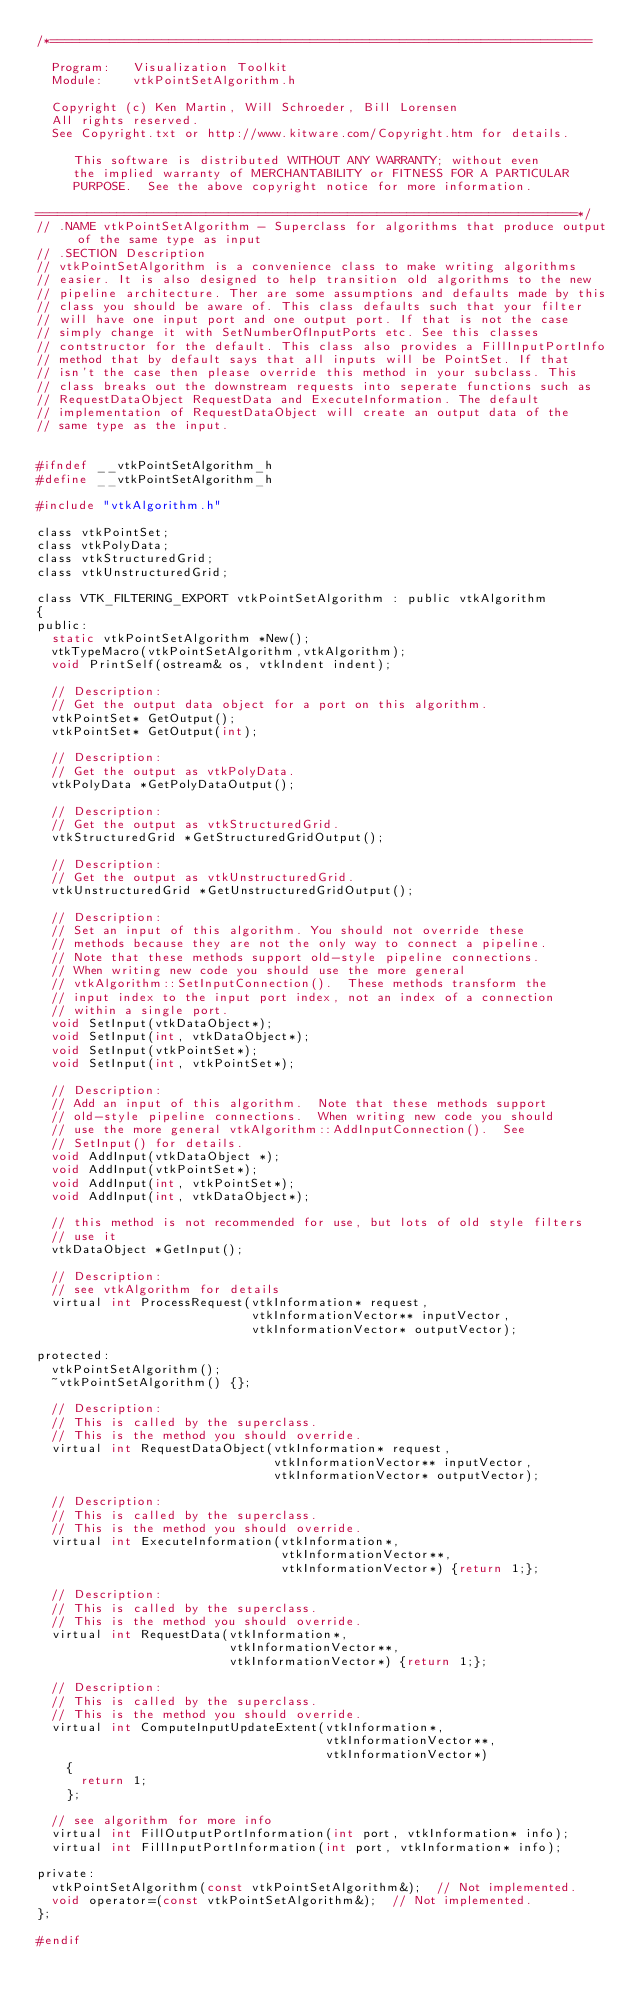<code> <loc_0><loc_0><loc_500><loc_500><_C_>/*=========================================================================

  Program:   Visualization Toolkit
  Module:    vtkPointSetAlgorithm.h

  Copyright (c) Ken Martin, Will Schroeder, Bill Lorensen
  All rights reserved.
  See Copyright.txt or http://www.kitware.com/Copyright.htm for details.

     This software is distributed WITHOUT ANY WARRANTY; without even
     the implied warranty of MERCHANTABILITY or FITNESS FOR A PARTICULAR
     PURPOSE.  See the above copyright notice for more information.

=========================================================================*/
// .NAME vtkPointSetAlgorithm - Superclass for algorithms that produce output of the same type as input
// .SECTION Description
// vtkPointSetAlgorithm is a convenience class to make writing algorithms
// easier. It is also designed to help transition old algorithms to the new
// pipeline architecture. Ther are some assumptions and defaults made by this
// class you should be aware of. This class defaults such that your filter
// will have one input port and one output port. If that is not the case
// simply change it with SetNumberOfInputPorts etc. See this classes
// contstructor for the default. This class also provides a FillInputPortInfo
// method that by default says that all inputs will be PointSet. If that
// isn't the case then please override this method in your subclass. This
// class breaks out the downstream requests into seperate functions such as
// RequestDataObject RequestData and ExecuteInformation. The default 
// implementation of RequestDataObject will create an output data of the 
// same type as the input. 


#ifndef __vtkPointSetAlgorithm_h
#define __vtkPointSetAlgorithm_h

#include "vtkAlgorithm.h"

class vtkPointSet;
class vtkPolyData;
class vtkStructuredGrid;
class vtkUnstructuredGrid;

class VTK_FILTERING_EXPORT vtkPointSetAlgorithm : public vtkAlgorithm
{
public:
  static vtkPointSetAlgorithm *New();
  vtkTypeMacro(vtkPointSetAlgorithm,vtkAlgorithm);
  void PrintSelf(ostream& os, vtkIndent indent);

  // Description:
  // Get the output data object for a port on this algorithm.
  vtkPointSet* GetOutput();
  vtkPointSet* GetOutput(int);

  // Description:
  // Get the output as vtkPolyData.
  vtkPolyData *GetPolyDataOutput();

  // Description:
  // Get the output as vtkStructuredGrid.
  vtkStructuredGrid *GetStructuredGridOutput();

  // Description:
  // Get the output as vtkUnstructuredGrid.
  vtkUnstructuredGrid *GetUnstructuredGridOutput();

  // Description:
  // Set an input of this algorithm. You should not override these
  // methods because they are not the only way to connect a pipeline.
  // Note that these methods support old-style pipeline connections.
  // When writing new code you should use the more general
  // vtkAlgorithm::SetInputConnection().  These methods transform the
  // input index to the input port index, not an index of a connection
  // within a single port.
  void SetInput(vtkDataObject*);
  void SetInput(int, vtkDataObject*);
  void SetInput(vtkPointSet*);
  void SetInput(int, vtkPointSet*);

  // Description:
  // Add an input of this algorithm.  Note that these methods support
  // old-style pipeline connections.  When writing new code you should
  // use the more general vtkAlgorithm::AddInputConnection().  See
  // SetInput() for details.
  void AddInput(vtkDataObject *);
  void AddInput(vtkPointSet*);
  void AddInput(int, vtkPointSet*);
  void AddInput(int, vtkDataObject*);

  // this method is not recommended for use, but lots of old style filters
  // use it
  vtkDataObject *GetInput();

  // Description:
  // see vtkAlgorithm for details
  virtual int ProcessRequest(vtkInformation* request, 
                             vtkInformationVector** inputVector,
                             vtkInformationVector* outputVector);

protected:
  vtkPointSetAlgorithm();
  ~vtkPointSetAlgorithm() {};
  
  // Description:
  // This is called by the superclass.
  // This is the method you should override.
  virtual int RequestDataObject(vtkInformation* request, 
                                vtkInformationVector** inputVector, 
                                vtkInformationVector* outputVector);
  
  // Description:
  // This is called by the superclass.
  // This is the method you should override.
  virtual int ExecuteInformation(vtkInformation*, 
                                 vtkInformationVector**, 
                                 vtkInformationVector*) {return 1;};
  
  // Description:
  // This is called by the superclass.
  // This is the method you should override.
  virtual int RequestData(vtkInformation*, 
                          vtkInformationVector**, 
                          vtkInformationVector*) {return 1;};
  
  // Description:
  // This is called by the superclass.
  // This is the method you should override.
  virtual int ComputeInputUpdateExtent(vtkInformation*,
                                       vtkInformationVector**,
                                       vtkInformationVector*) 
    {
      return 1;
    };

  // see algorithm for more info
  virtual int FillOutputPortInformation(int port, vtkInformation* info);
  virtual int FillInputPortInformation(int port, vtkInformation* info);

private:
  vtkPointSetAlgorithm(const vtkPointSetAlgorithm&);  // Not implemented.
  void operator=(const vtkPointSetAlgorithm&);  // Not implemented.
};

#endif
</code> 